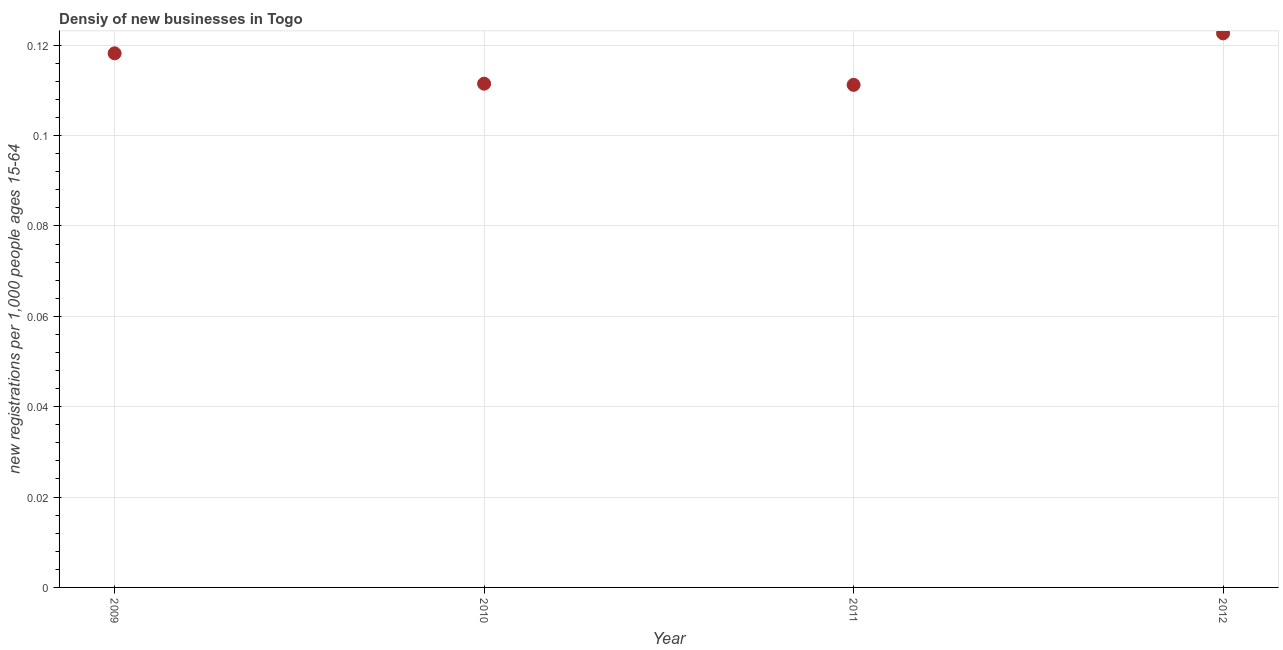What is the density of new business in 2011?
Make the answer very short. 0.11. Across all years, what is the maximum density of new business?
Keep it short and to the point. 0.12. Across all years, what is the minimum density of new business?
Keep it short and to the point. 0.11. In which year was the density of new business maximum?
Your response must be concise. 2012. In which year was the density of new business minimum?
Your answer should be very brief. 2011. What is the sum of the density of new business?
Keep it short and to the point. 0.46. What is the difference between the density of new business in 2009 and 2012?
Provide a short and direct response. -0. What is the average density of new business per year?
Provide a succinct answer. 0.12. What is the median density of new business?
Keep it short and to the point. 0.11. In how many years, is the density of new business greater than 0.116 ?
Give a very brief answer. 2. Do a majority of the years between 2011 and 2010 (inclusive) have density of new business greater than 0.052000000000000005 ?
Offer a terse response. No. What is the ratio of the density of new business in 2009 to that in 2011?
Your answer should be very brief. 1.06. Is the density of new business in 2009 less than that in 2010?
Offer a very short reply. No. What is the difference between the highest and the second highest density of new business?
Give a very brief answer. 0. What is the difference between the highest and the lowest density of new business?
Provide a succinct answer. 0.01. In how many years, is the density of new business greater than the average density of new business taken over all years?
Give a very brief answer. 2. How many dotlines are there?
Ensure brevity in your answer.  1. What is the difference between two consecutive major ticks on the Y-axis?
Offer a terse response. 0.02. Are the values on the major ticks of Y-axis written in scientific E-notation?
Your answer should be compact. No. Does the graph contain any zero values?
Make the answer very short. No. Does the graph contain grids?
Provide a short and direct response. Yes. What is the title of the graph?
Offer a very short reply. Densiy of new businesses in Togo. What is the label or title of the Y-axis?
Offer a terse response. New registrations per 1,0 people ages 15-64. What is the new registrations per 1,000 people ages 15-64 in 2009?
Give a very brief answer. 0.12. What is the new registrations per 1,000 people ages 15-64 in 2010?
Your answer should be very brief. 0.11. What is the new registrations per 1,000 people ages 15-64 in 2011?
Your answer should be very brief. 0.11. What is the new registrations per 1,000 people ages 15-64 in 2012?
Your answer should be very brief. 0.12. What is the difference between the new registrations per 1,000 people ages 15-64 in 2009 and 2010?
Ensure brevity in your answer.  0.01. What is the difference between the new registrations per 1,000 people ages 15-64 in 2009 and 2011?
Your response must be concise. 0.01. What is the difference between the new registrations per 1,000 people ages 15-64 in 2009 and 2012?
Give a very brief answer. -0. What is the difference between the new registrations per 1,000 people ages 15-64 in 2010 and 2011?
Provide a short and direct response. 0. What is the difference between the new registrations per 1,000 people ages 15-64 in 2010 and 2012?
Offer a terse response. -0.01. What is the difference between the new registrations per 1,000 people ages 15-64 in 2011 and 2012?
Make the answer very short. -0.01. What is the ratio of the new registrations per 1,000 people ages 15-64 in 2009 to that in 2010?
Offer a terse response. 1.06. What is the ratio of the new registrations per 1,000 people ages 15-64 in 2009 to that in 2011?
Your answer should be very brief. 1.06. What is the ratio of the new registrations per 1,000 people ages 15-64 in 2009 to that in 2012?
Offer a terse response. 0.96. What is the ratio of the new registrations per 1,000 people ages 15-64 in 2010 to that in 2011?
Your answer should be compact. 1. What is the ratio of the new registrations per 1,000 people ages 15-64 in 2010 to that in 2012?
Your response must be concise. 0.91. What is the ratio of the new registrations per 1,000 people ages 15-64 in 2011 to that in 2012?
Keep it short and to the point. 0.91. 